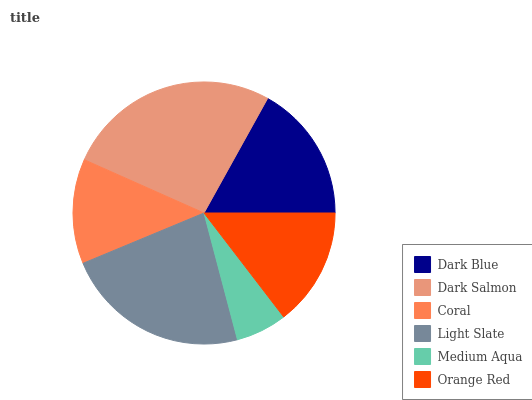Is Medium Aqua the minimum?
Answer yes or no. Yes. Is Dark Salmon the maximum?
Answer yes or no. Yes. Is Coral the minimum?
Answer yes or no. No. Is Coral the maximum?
Answer yes or no. No. Is Dark Salmon greater than Coral?
Answer yes or no. Yes. Is Coral less than Dark Salmon?
Answer yes or no. Yes. Is Coral greater than Dark Salmon?
Answer yes or no. No. Is Dark Salmon less than Coral?
Answer yes or no. No. Is Dark Blue the high median?
Answer yes or no. Yes. Is Orange Red the low median?
Answer yes or no. Yes. Is Dark Salmon the high median?
Answer yes or no. No. Is Medium Aqua the low median?
Answer yes or no. No. 